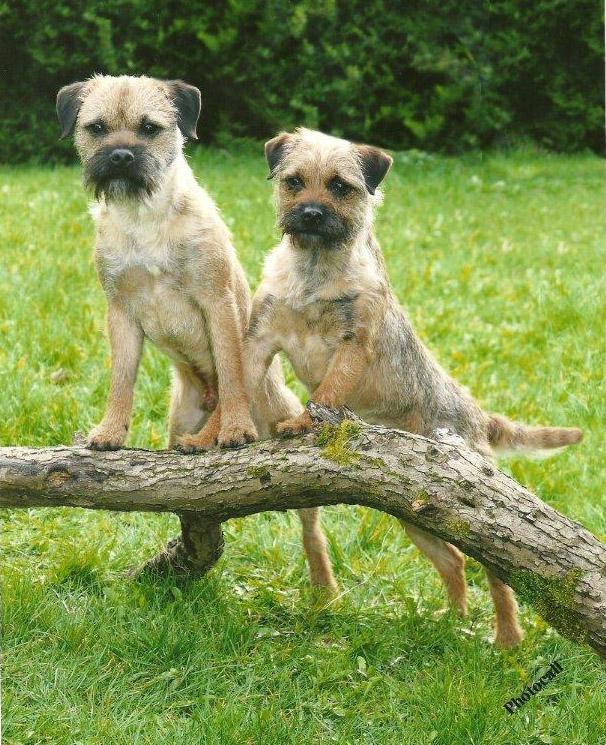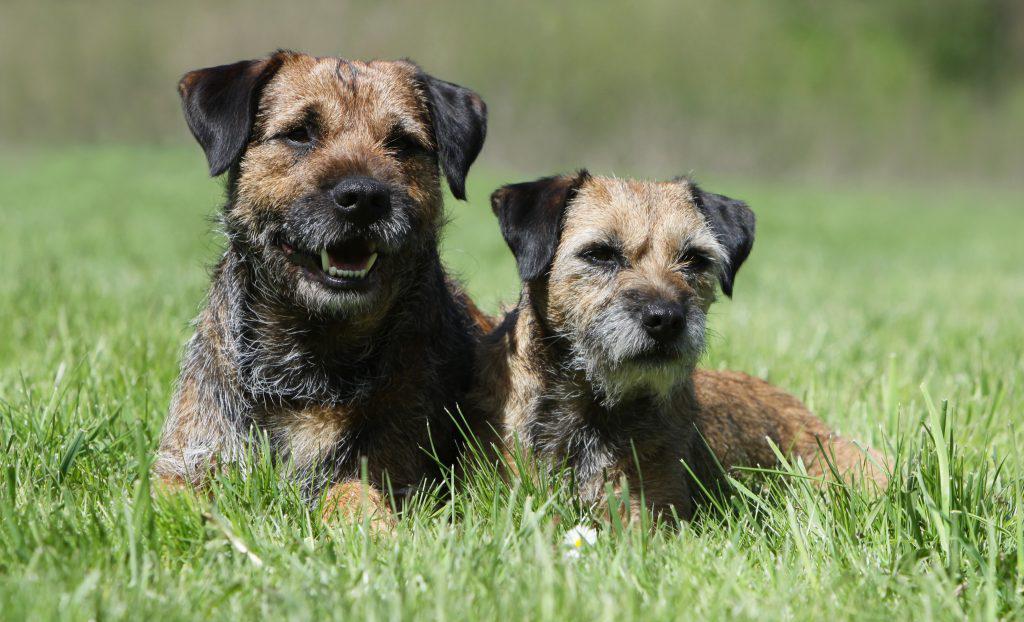The first image is the image on the left, the second image is the image on the right. Analyze the images presented: Is the assertion "An image shows two dogs resting together with something pillow-like." valid? Answer yes or no. No. The first image is the image on the left, the second image is the image on the right. For the images displayed, is the sentence "At least one image shows two dogs napping together." factually correct? Answer yes or no. No. The first image is the image on the left, the second image is the image on the right. Examine the images to the left and right. Is the description "Two terriers are standing in the grass with their front paws on a branch." accurate? Answer yes or no. Yes. The first image is the image on the left, the second image is the image on the right. Considering the images on both sides, is "In one of the images there are two dogs resting their heads on a pillow." valid? Answer yes or no. No. 